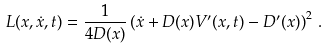<formula> <loc_0><loc_0><loc_500><loc_500>L ( x , \dot { x } , t ) = \frac { 1 } { 4 D ( x ) } \left ( \dot { x } + D ( x ) V ^ { \prime } ( x , t ) - D ^ { \prime } ( x ) \right ) ^ { 2 } \, .</formula> 